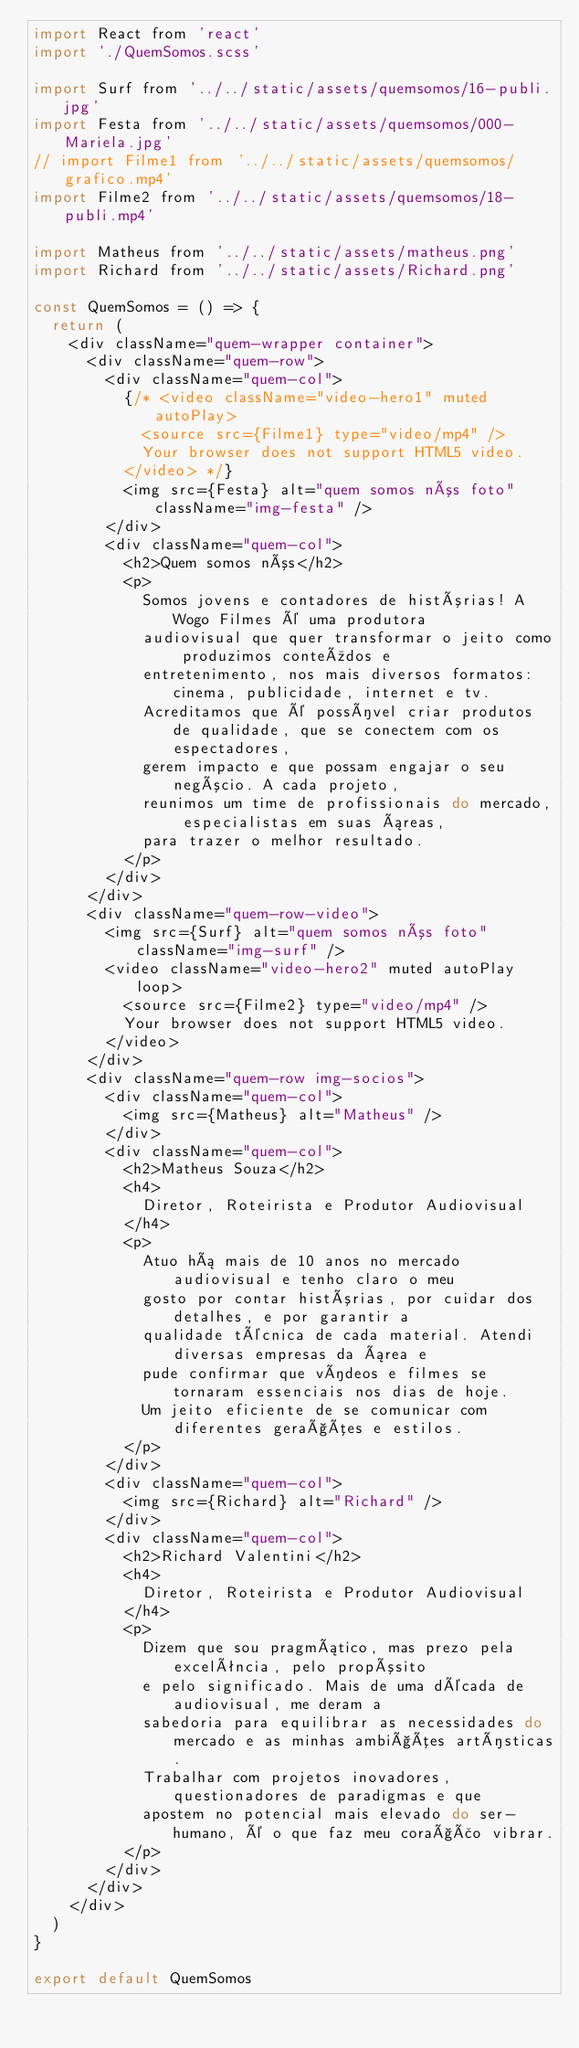<code> <loc_0><loc_0><loc_500><loc_500><_JavaScript_>import React from 'react'
import './QuemSomos.scss'

import Surf from '../../static/assets/quemsomos/16-publi.jpg'
import Festa from '../../static/assets/quemsomos/000-Mariela.jpg'
// import Filme1 from '../../static/assets/quemsomos/grafico.mp4'
import Filme2 from '../../static/assets/quemsomos/18-publi.mp4'

import Matheus from '../../static/assets/matheus.png'
import Richard from '../../static/assets/Richard.png'

const QuemSomos = () => {
  return (
    <div className="quem-wrapper container">
      <div className="quem-row">
        <div className="quem-col">
          {/* <video className="video-hero1" muted autoPlay>
            <source src={Filme1} type="video/mp4" />
            Your browser does not support HTML5 video.
          </video> */}
          <img src={Festa} alt="quem somos nós foto" className="img-festa" />
        </div>
        <div className="quem-col">
          <h2>Quem somos nós</h2>
          <p>
            Somos jovens e contadores de histórias! A Wogo Filmes é uma produtora
            audiovisual que quer transformar o jeito como produzimos conteúdos e
            entretenimento, nos mais diversos formatos: cinema, publicidade, internet e tv.
            Acreditamos que é possível criar produtos de qualidade, que se conectem com os espectadores,
            gerem impacto e que possam engajar o seu negócio. A cada projeto,
            reunimos um time de profissionais do mercado, especialistas em suas áreas,
            para trazer o melhor resultado.
          </p>
        </div>
      </div>
      <div className="quem-row-video">
        <img src={Surf} alt="quem somos nós foto" className="img-surf" />
        <video className="video-hero2" muted autoPlay loop>
          <source src={Filme2} type="video/mp4" />
          Your browser does not support HTML5 video.
        </video>
      </div>
      <div className="quem-row img-socios">
        <div className="quem-col">
          <img src={Matheus} alt="Matheus" />
        </div>
        <div className="quem-col">
          <h2>Matheus Souza</h2>
          <h4>
            Diretor, Roteirista e Produtor Audiovisual
          </h4>
          <p>
            Atuo há mais de 10 anos no mercado audiovisual e tenho claro o meu
            gosto por contar histórias, por cuidar dos detalhes, e por garantir a
            qualidade técnica de cada material. Atendi diversas empresas da área e
            pude confirmar que vídeos e filmes se tornaram essenciais nos dias de hoje.
            Um jeito eficiente de se comunicar com diferentes gerações e estilos.
          </p>
        </div>
        <div className="quem-col">
          <img src={Richard} alt="Richard" />
        </div>
        <div className="quem-col">
          <h2>Richard Valentini</h2>
          <h4>
            Diretor, Roteirista e Produtor Audiovisual
          </h4>
          <p>
            Dizem que sou pragmático, mas prezo pela excelência, pelo propósito
            e pelo significado. Mais de uma década de audiovisual, me deram a
            sabedoria para equilibrar as necessidades do mercado e as minhas ambições artísticas.
            Trabalhar com projetos inovadores, questionadores de paradigmas e que
            apostem no potencial mais elevado do ser-humano, é o que faz meu coração vibrar.
          </p>
        </div>
      </div>
    </div>
  )
}

export default QuemSomos
</code> 